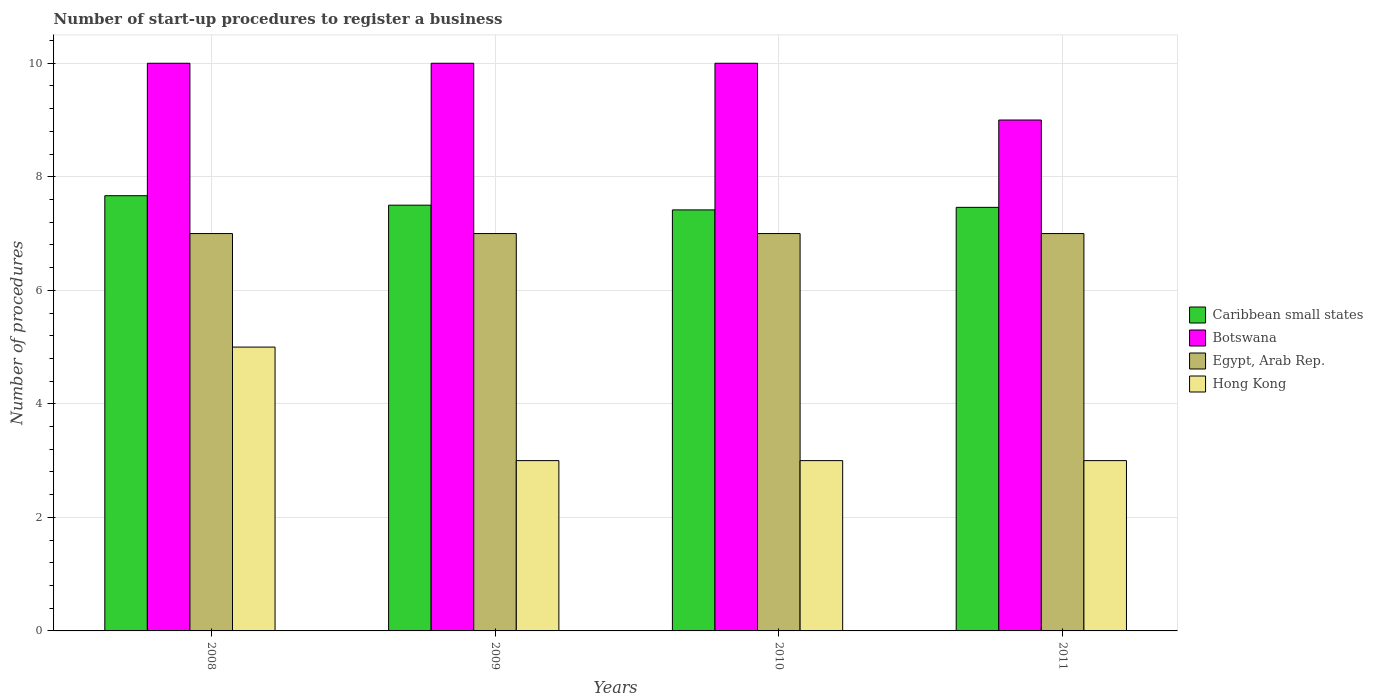How many different coloured bars are there?
Offer a terse response. 4. Are the number of bars per tick equal to the number of legend labels?
Give a very brief answer. Yes. How many bars are there on the 2nd tick from the left?
Your answer should be very brief. 4. How many bars are there on the 1st tick from the right?
Offer a very short reply. 4. What is the label of the 2nd group of bars from the left?
Offer a terse response. 2009. In how many cases, is the number of bars for a given year not equal to the number of legend labels?
Provide a short and direct response. 0. What is the number of procedures required to register a business in Caribbean small states in 2008?
Your answer should be compact. 7.67. Across all years, what is the maximum number of procedures required to register a business in Egypt, Arab Rep.?
Keep it short and to the point. 7. Across all years, what is the minimum number of procedures required to register a business in Egypt, Arab Rep.?
Ensure brevity in your answer.  7. What is the total number of procedures required to register a business in Botswana in the graph?
Offer a terse response. 39. What is the difference between the number of procedures required to register a business in Caribbean small states in 2011 and the number of procedures required to register a business in Egypt, Arab Rep. in 2009?
Ensure brevity in your answer.  0.46. In the year 2011, what is the difference between the number of procedures required to register a business in Egypt, Arab Rep. and number of procedures required to register a business in Hong Kong?
Make the answer very short. 4. In how many years, is the number of procedures required to register a business in Hong Kong greater than 6?
Ensure brevity in your answer.  0. What is the ratio of the number of procedures required to register a business in Botswana in 2008 to that in 2011?
Offer a terse response. 1.11. What is the difference between the highest and the second highest number of procedures required to register a business in Hong Kong?
Offer a very short reply. 2. What is the difference between the highest and the lowest number of procedures required to register a business in Botswana?
Make the answer very short. 1. Is it the case that in every year, the sum of the number of procedures required to register a business in Egypt, Arab Rep. and number of procedures required to register a business in Caribbean small states is greater than the sum of number of procedures required to register a business in Botswana and number of procedures required to register a business in Hong Kong?
Offer a terse response. Yes. What does the 1st bar from the left in 2008 represents?
Your response must be concise. Caribbean small states. What does the 2nd bar from the right in 2010 represents?
Give a very brief answer. Egypt, Arab Rep. Are the values on the major ticks of Y-axis written in scientific E-notation?
Make the answer very short. No. Does the graph contain any zero values?
Ensure brevity in your answer.  No. Where does the legend appear in the graph?
Your answer should be compact. Center right. How are the legend labels stacked?
Your response must be concise. Vertical. What is the title of the graph?
Offer a terse response. Number of start-up procedures to register a business. What is the label or title of the X-axis?
Give a very brief answer. Years. What is the label or title of the Y-axis?
Your response must be concise. Number of procedures. What is the Number of procedures in Caribbean small states in 2008?
Offer a very short reply. 7.67. What is the Number of procedures of Egypt, Arab Rep. in 2008?
Give a very brief answer. 7. What is the Number of procedures in Botswana in 2009?
Your answer should be compact. 10. What is the Number of procedures of Caribbean small states in 2010?
Your response must be concise. 7.42. What is the Number of procedures of Egypt, Arab Rep. in 2010?
Your answer should be very brief. 7. What is the Number of procedures in Caribbean small states in 2011?
Your answer should be compact. 7.46. What is the Number of procedures of Botswana in 2011?
Make the answer very short. 9. Across all years, what is the maximum Number of procedures in Caribbean small states?
Your answer should be compact. 7.67. Across all years, what is the maximum Number of procedures in Botswana?
Offer a very short reply. 10. Across all years, what is the minimum Number of procedures in Caribbean small states?
Provide a succinct answer. 7.42. Across all years, what is the minimum Number of procedures of Botswana?
Provide a short and direct response. 9. What is the total Number of procedures in Caribbean small states in the graph?
Ensure brevity in your answer.  30.04. What is the total Number of procedures in Botswana in the graph?
Make the answer very short. 39. What is the total Number of procedures of Hong Kong in the graph?
Provide a succinct answer. 14. What is the difference between the Number of procedures in Egypt, Arab Rep. in 2008 and that in 2010?
Your response must be concise. 0. What is the difference between the Number of procedures of Caribbean small states in 2008 and that in 2011?
Offer a very short reply. 0.21. What is the difference between the Number of procedures of Hong Kong in 2008 and that in 2011?
Your response must be concise. 2. What is the difference between the Number of procedures of Caribbean small states in 2009 and that in 2010?
Provide a succinct answer. 0.08. What is the difference between the Number of procedures of Botswana in 2009 and that in 2010?
Ensure brevity in your answer.  0. What is the difference between the Number of procedures of Egypt, Arab Rep. in 2009 and that in 2010?
Your response must be concise. 0. What is the difference between the Number of procedures of Caribbean small states in 2009 and that in 2011?
Give a very brief answer. 0.04. What is the difference between the Number of procedures in Botswana in 2009 and that in 2011?
Ensure brevity in your answer.  1. What is the difference between the Number of procedures in Egypt, Arab Rep. in 2009 and that in 2011?
Your answer should be very brief. 0. What is the difference between the Number of procedures in Hong Kong in 2009 and that in 2011?
Provide a short and direct response. 0. What is the difference between the Number of procedures of Caribbean small states in 2010 and that in 2011?
Make the answer very short. -0.04. What is the difference between the Number of procedures in Botswana in 2010 and that in 2011?
Your response must be concise. 1. What is the difference between the Number of procedures in Caribbean small states in 2008 and the Number of procedures in Botswana in 2009?
Provide a short and direct response. -2.33. What is the difference between the Number of procedures of Caribbean small states in 2008 and the Number of procedures of Hong Kong in 2009?
Provide a short and direct response. 4.67. What is the difference between the Number of procedures in Botswana in 2008 and the Number of procedures in Hong Kong in 2009?
Provide a succinct answer. 7. What is the difference between the Number of procedures in Egypt, Arab Rep. in 2008 and the Number of procedures in Hong Kong in 2009?
Your answer should be very brief. 4. What is the difference between the Number of procedures of Caribbean small states in 2008 and the Number of procedures of Botswana in 2010?
Ensure brevity in your answer.  -2.33. What is the difference between the Number of procedures of Caribbean small states in 2008 and the Number of procedures of Egypt, Arab Rep. in 2010?
Your response must be concise. 0.67. What is the difference between the Number of procedures in Caribbean small states in 2008 and the Number of procedures in Hong Kong in 2010?
Offer a terse response. 4.67. What is the difference between the Number of procedures of Caribbean small states in 2008 and the Number of procedures of Botswana in 2011?
Your response must be concise. -1.33. What is the difference between the Number of procedures of Caribbean small states in 2008 and the Number of procedures of Hong Kong in 2011?
Give a very brief answer. 4.67. What is the difference between the Number of procedures of Botswana in 2008 and the Number of procedures of Egypt, Arab Rep. in 2011?
Provide a succinct answer. 3. What is the difference between the Number of procedures in Egypt, Arab Rep. in 2008 and the Number of procedures in Hong Kong in 2011?
Provide a short and direct response. 4. What is the difference between the Number of procedures of Caribbean small states in 2009 and the Number of procedures of Egypt, Arab Rep. in 2010?
Your response must be concise. 0.5. What is the difference between the Number of procedures of Caribbean small states in 2009 and the Number of procedures of Hong Kong in 2010?
Give a very brief answer. 4.5. What is the difference between the Number of procedures of Botswana in 2009 and the Number of procedures of Egypt, Arab Rep. in 2010?
Give a very brief answer. 3. What is the difference between the Number of procedures of Botswana in 2009 and the Number of procedures of Hong Kong in 2010?
Ensure brevity in your answer.  7. What is the difference between the Number of procedures of Caribbean small states in 2009 and the Number of procedures of Egypt, Arab Rep. in 2011?
Your answer should be compact. 0.5. What is the difference between the Number of procedures in Botswana in 2009 and the Number of procedures in Egypt, Arab Rep. in 2011?
Ensure brevity in your answer.  3. What is the difference between the Number of procedures in Egypt, Arab Rep. in 2009 and the Number of procedures in Hong Kong in 2011?
Offer a very short reply. 4. What is the difference between the Number of procedures of Caribbean small states in 2010 and the Number of procedures of Botswana in 2011?
Give a very brief answer. -1.58. What is the difference between the Number of procedures in Caribbean small states in 2010 and the Number of procedures in Egypt, Arab Rep. in 2011?
Keep it short and to the point. 0.42. What is the difference between the Number of procedures of Caribbean small states in 2010 and the Number of procedures of Hong Kong in 2011?
Offer a very short reply. 4.42. What is the average Number of procedures of Caribbean small states per year?
Offer a terse response. 7.51. What is the average Number of procedures in Botswana per year?
Make the answer very short. 9.75. What is the average Number of procedures of Egypt, Arab Rep. per year?
Offer a terse response. 7. What is the average Number of procedures in Hong Kong per year?
Make the answer very short. 3.5. In the year 2008, what is the difference between the Number of procedures in Caribbean small states and Number of procedures in Botswana?
Your response must be concise. -2.33. In the year 2008, what is the difference between the Number of procedures of Caribbean small states and Number of procedures of Egypt, Arab Rep.?
Your response must be concise. 0.67. In the year 2008, what is the difference between the Number of procedures in Caribbean small states and Number of procedures in Hong Kong?
Your answer should be compact. 2.67. In the year 2008, what is the difference between the Number of procedures of Botswana and Number of procedures of Egypt, Arab Rep.?
Ensure brevity in your answer.  3. In the year 2009, what is the difference between the Number of procedures of Caribbean small states and Number of procedures of Botswana?
Ensure brevity in your answer.  -2.5. In the year 2009, what is the difference between the Number of procedures in Caribbean small states and Number of procedures in Hong Kong?
Offer a terse response. 4.5. In the year 2009, what is the difference between the Number of procedures of Botswana and Number of procedures of Hong Kong?
Provide a short and direct response. 7. In the year 2009, what is the difference between the Number of procedures in Egypt, Arab Rep. and Number of procedures in Hong Kong?
Provide a succinct answer. 4. In the year 2010, what is the difference between the Number of procedures of Caribbean small states and Number of procedures of Botswana?
Keep it short and to the point. -2.58. In the year 2010, what is the difference between the Number of procedures of Caribbean small states and Number of procedures of Egypt, Arab Rep.?
Offer a very short reply. 0.42. In the year 2010, what is the difference between the Number of procedures in Caribbean small states and Number of procedures in Hong Kong?
Make the answer very short. 4.42. In the year 2011, what is the difference between the Number of procedures in Caribbean small states and Number of procedures in Botswana?
Your answer should be compact. -1.54. In the year 2011, what is the difference between the Number of procedures of Caribbean small states and Number of procedures of Egypt, Arab Rep.?
Ensure brevity in your answer.  0.46. In the year 2011, what is the difference between the Number of procedures in Caribbean small states and Number of procedures in Hong Kong?
Give a very brief answer. 4.46. In the year 2011, what is the difference between the Number of procedures of Botswana and Number of procedures of Egypt, Arab Rep.?
Your response must be concise. 2. In the year 2011, what is the difference between the Number of procedures of Botswana and Number of procedures of Hong Kong?
Offer a very short reply. 6. In the year 2011, what is the difference between the Number of procedures of Egypt, Arab Rep. and Number of procedures of Hong Kong?
Give a very brief answer. 4. What is the ratio of the Number of procedures of Caribbean small states in 2008 to that in 2009?
Make the answer very short. 1.02. What is the ratio of the Number of procedures of Egypt, Arab Rep. in 2008 to that in 2009?
Give a very brief answer. 1. What is the ratio of the Number of procedures in Hong Kong in 2008 to that in 2009?
Provide a succinct answer. 1.67. What is the ratio of the Number of procedures in Caribbean small states in 2008 to that in 2010?
Your answer should be very brief. 1.03. What is the ratio of the Number of procedures in Hong Kong in 2008 to that in 2010?
Keep it short and to the point. 1.67. What is the ratio of the Number of procedures in Caribbean small states in 2008 to that in 2011?
Your response must be concise. 1.03. What is the ratio of the Number of procedures in Egypt, Arab Rep. in 2008 to that in 2011?
Your answer should be very brief. 1. What is the ratio of the Number of procedures of Caribbean small states in 2009 to that in 2010?
Provide a short and direct response. 1.01. What is the ratio of the Number of procedures of Hong Kong in 2009 to that in 2011?
Your answer should be compact. 1. What is the ratio of the Number of procedures in Hong Kong in 2010 to that in 2011?
Your response must be concise. 1. What is the difference between the highest and the second highest Number of procedures in Caribbean small states?
Give a very brief answer. 0.17. What is the difference between the highest and the second highest Number of procedures in Hong Kong?
Ensure brevity in your answer.  2. What is the difference between the highest and the lowest Number of procedures in Caribbean small states?
Ensure brevity in your answer.  0.25. What is the difference between the highest and the lowest Number of procedures in Hong Kong?
Make the answer very short. 2. 